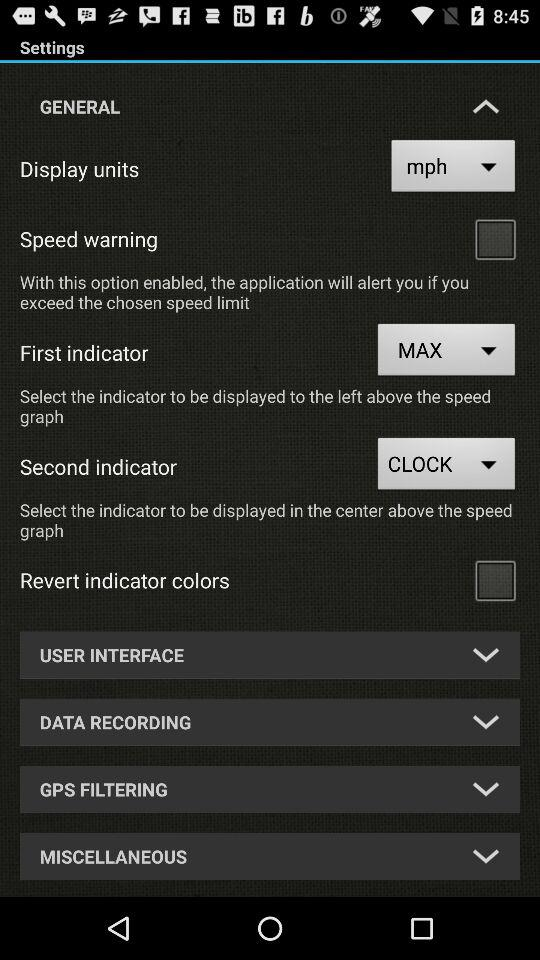What display unit is selected? The selected display unit is mph. 